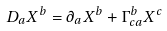<formula> <loc_0><loc_0><loc_500><loc_500>D _ { a } X ^ { b } = \partial _ { a } X ^ { b } + \Gamma ^ { b } _ { c a } X ^ { c }</formula> 